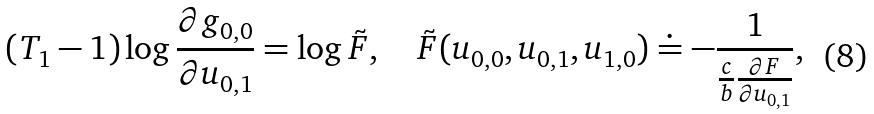<formula> <loc_0><loc_0><loc_500><loc_500>( T _ { 1 } - 1 ) \log \frac { \partial g _ { 0 , 0 } } { \partial u _ { 0 , 1 } } = \log \tilde { F } , \quad \tilde { F } ( u _ { 0 , 0 } , u _ { 0 , 1 } , u _ { 1 , 0 } ) \doteq - \frac { 1 } { \frac { c } { b } \frac { \partial F } { \partial u _ { 0 , 1 } } } ,</formula> 